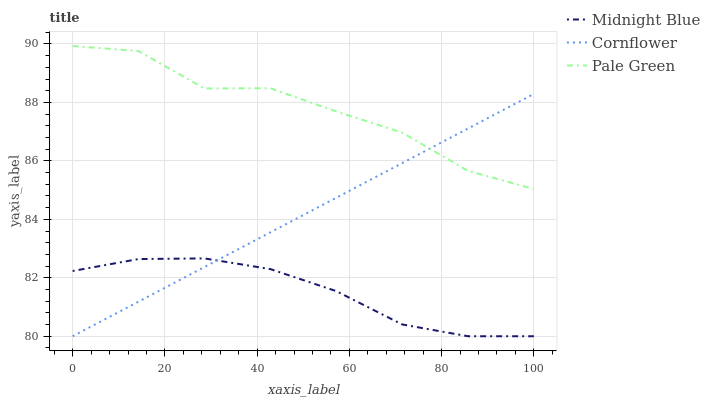Does Midnight Blue have the minimum area under the curve?
Answer yes or no. Yes. Does Pale Green have the maximum area under the curve?
Answer yes or no. Yes. Does Pale Green have the minimum area under the curve?
Answer yes or no. No. Does Midnight Blue have the maximum area under the curve?
Answer yes or no. No. Is Cornflower the smoothest?
Answer yes or no. Yes. Is Pale Green the roughest?
Answer yes or no. Yes. Is Midnight Blue the smoothest?
Answer yes or no. No. Is Midnight Blue the roughest?
Answer yes or no. No. Does Cornflower have the lowest value?
Answer yes or no. Yes. Does Pale Green have the lowest value?
Answer yes or no. No. Does Pale Green have the highest value?
Answer yes or no. Yes. Does Midnight Blue have the highest value?
Answer yes or no. No. Is Midnight Blue less than Pale Green?
Answer yes or no. Yes. Is Pale Green greater than Midnight Blue?
Answer yes or no. Yes. Does Midnight Blue intersect Cornflower?
Answer yes or no. Yes. Is Midnight Blue less than Cornflower?
Answer yes or no. No. Is Midnight Blue greater than Cornflower?
Answer yes or no. No. Does Midnight Blue intersect Pale Green?
Answer yes or no. No. 